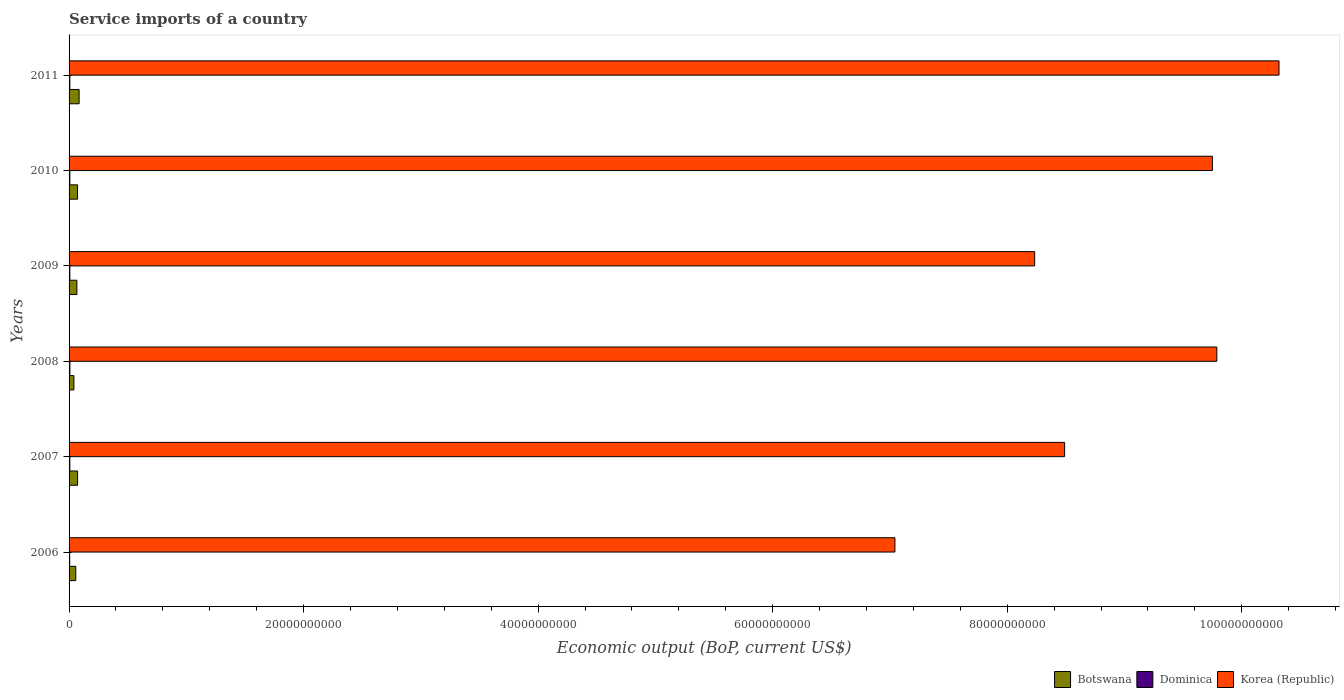How many different coloured bars are there?
Make the answer very short. 3. How many groups of bars are there?
Keep it short and to the point. 6. Are the number of bars per tick equal to the number of legend labels?
Provide a short and direct response. Yes. How many bars are there on the 3rd tick from the bottom?
Make the answer very short. 3. What is the label of the 5th group of bars from the top?
Offer a very short reply. 2007. What is the service imports in Botswana in 2006?
Your response must be concise. 5.72e+08. Across all years, what is the maximum service imports in Botswana?
Make the answer very short. 8.56e+08. Across all years, what is the minimum service imports in Korea (Republic)?
Your response must be concise. 7.04e+1. In which year was the service imports in Korea (Republic) maximum?
Keep it short and to the point. 2011. In which year was the service imports in Dominica minimum?
Provide a short and direct response. 2006. What is the total service imports in Korea (Republic) in the graph?
Make the answer very short. 5.36e+11. What is the difference between the service imports in Dominica in 2009 and that in 2010?
Your answer should be very brief. -1.36e+06. What is the difference between the service imports in Botswana in 2009 and the service imports in Dominica in 2011?
Your response must be concise. 6.01e+08. What is the average service imports in Korea (Republic) per year?
Your answer should be compact. 8.94e+1. In the year 2009, what is the difference between the service imports in Botswana and service imports in Dominica?
Your answer should be compact. 6.00e+08. In how many years, is the service imports in Dominica greater than 88000000000 US$?
Your answer should be very brief. 0. What is the ratio of the service imports in Korea (Republic) in 2006 to that in 2007?
Your answer should be compact. 0.83. Is the service imports in Korea (Republic) in 2010 less than that in 2011?
Your answer should be very brief. Yes. Is the difference between the service imports in Botswana in 2009 and 2011 greater than the difference between the service imports in Dominica in 2009 and 2011?
Offer a very short reply. No. What is the difference between the highest and the second highest service imports in Dominica?
Your answer should be very brief. 2.35e+06. What is the difference between the highest and the lowest service imports in Dominica?
Your answer should be very brief. 1.80e+07. Is the sum of the service imports in Botswana in 2006 and 2008 greater than the maximum service imports in Dominica across all years?
Offer a very short reply. Yes. What does the 3rd bar from the top in 2006 represents?
Make the answer very short. Botswana. What does the 2nd bar from the bottom in 2007 represents?
Give a very brief answer. Dominica. How many bars are there?
Your answer should be very brief. 18. Are the values on the major ticks of X-axis written in scientific E-notation?
Your answer should be very brief. No. Does the graph contain any zero values?
Make the answer very short. No. Does the graph contain grids?
Ensure brevity in your answer.  No. Where does the legend appear in the graph?
Make the answer very short. Bottom right. How are the legend labels stacked?
Make the answer very short. Horizontal. What is the title of the graph?
Offer a terse response. Service imports of a country. What is the label or title of the X-axis?
Make the answer very short. Economic output (BoP, current US$). What is the label or title of the Y-axis?
Your response must be concise. Years. What is the Economic output (BoP, current US$) in Botswana in 2006?
Provide a short and direct response. 5.72e+08. What is the Economic output (BoP, current US$) in Dominica in 2006?
Your response must be concise. 5.20e+07. What is the Economic output (BoP, current US$) in Korea (Republic) in 2006?
Give a very brief answer. 7.04e+1. What is the Economic output (BoP, current US$) of Botswana in 2007?
Your response must be concise. 7.27e+08. What is the Economic output (BoP, current US$) in Dominica in 2007?
Offer a very short reply. 6.40e+07. What is the Economic output (BoP, current US$) in Korea (Republic) in 2007?
Keep it short and to the point. 8.49e+1. What is the Economic output (BoP, current US$) of Botswana in 2008?
Your answer should be very brief. 4.12e+08. What is the Economic output (BoP, current US$) in Dominica in 2008?
Offer a very short reply. 6.99e+07. What is the Economic output (BoP, current US$) in Korea (Republic) in 2008?
Offer a very short reply. 9.79e+1. What is the Economic output (BoP, current US$) in Botswana in 2009?
Provide a succinct answer. 6.67e+08. What is the Economic output (BoP, current US$) in Dominica in 2009?
Your answer should be compact. 6.62e+07. What is the Economic output (BoP, current US$) of Korea (Republic) in 2009?
Provide a short and direct response. 8.23e+1. What is the Economic output (BoP, current US$) of Botswana in 2010?
Make the answer very short. 7.23e+08. What is the Economic output (BoP, current US$) in Dominica in 2010?
Make the answer very short. 6.76e+07. What is the Economic output (BoP, current US$) in Korea (Republic) in 2010?
Your answer should be very brief. 9.75e+1. What is the Economic output (BoP, current US$) in Botswana in 2011?
Give a very brief answer. 8.56e+08. What is the Economic output (BoP, current US$) in Dominica in 2011?
Provide a short and direct response. 6.59e+07. What is the Economic output (BoP, current US$) in Korea (Republic) in 2011?
Keep it short and to the point. 1.03e+11. Across all years, what is the maximum Economic output (BoP, current US$) of Botswana?
Provide a short and direct response. 8.56e+08. Across all years, what is the maximum Economic output (BoP, current US$) in Dominica?
Offer a very short reply. 6.99e+07. Across all years, what is the maximum Economic output (BoP, current US$) in Korea (Republic)?
Offer a very short reply. 1.03e+11. Across all years, what is the minimum Economic output (BoP, current US$) in Botswana?
Keep it short and to the point. 4.12e+08. Across all years, what is the minimum Economic output (BoP, current US$) of Dominica?
Your response must be concise. 5.20e+07. Across all years, what is the minimum Economic output (BoP, current US$) of Korea (Republic)?
Your response must be concise. 7.04e+1. What is the total Economic output (BoP, current US$) in Botswana in the graph?
Your response must be concise. 3.96e+09. What is the total Economic output (BoP, current US$) in Dominica in the graph?
Your answer should be very brief. 3.86e+08. What is the total Economic output (BoP, current US$) in Korea (Republic) in the graph?
Keep it short and to the point. 5.36e+11. What is the difference between the Economic output (BoP, current US$) in Botswana in 2006 and that in 2007?
Offer a terse response. -1.55e+08. What is the difference between the Economic output (BoP, current US$) in Dominica in 2006 and that in 2007?
Your response must be concise. -1.20e+07. What is the difference between the Economic output (BoP, current US$) in Korea (Republic) in 2006 and that in 2007?
Ensure brevity in your answer.  -1.45e+1. What is the difference between the Economic output (BoP, current US$) of Botswana in 2006 and that in 2008?
Ensure brevity in your answer.  1.60e+08. What is the difference between the Economic output (BoP, current US$) in Dominica in 2006 and that in 2008?
Your response must be concise. -1.80e+07. What is the difference between the Economic output (BoP, current US$) in Korea (Republic) in 2006 and that in 2008?
Ensure brevity in your answer.  -2.75e+1. What is the difference between the Economic output (BoP, current US$) of Botswana in 2006 and that in 2009?
Keep it short and to the point. -9.48e+07. What is the difference between the Economic output (BoP, current US$) in Dominica in 2006 and that in 2009?
Offer a terse response. -1.43e+07. What is the difference between the Economic output (BoP, current US$) in Korea (Republic) in 2006 and that in 2009?
Your answer should be very brief. -1.19e+1. What is the difference between the Economic output (BoP, current US$) of Botswana in 2006 and that in 2010?
Offer a very short reply. -1.51e+08. What is the difference between the Economic output (BoP, current US$) of Dominica in 2006 and that in 2010?
Your response must be concise. -1.56e+07. What is the difference between the Economic output (BoP, current US$) in Korea (Republic) in 2006 and that in 2010?
Your answer should be very brief. -2.71e+1. What is the difference between the Economic output (BoP, current US$) of Botswana in 2006 and that in 2011?
Offer a very short reply. -2.84e+08. What is the difference between the Economic output (BoP, current US$) in Dominica in 2006 and that in 2011?
Offer a very short reply. -1.39e+07. What is the difference between the Economic output (BoP, current US$) in Korea (Republic) in 2006 and that in 2011?
Your answer should be very brief. -3.28e+1. What is the difference between the Economic output (BoP, current US$) in Botswana in 2007 and that in 2008?
Your answer should be very brief. 3.16e+08. What is the difference between the Economic output (BoP, current US$) of Dominica in 2007 and that in 2008?
Ensure brevity in your answer.  -5.96e+06. What is the difference between the Economic output (BoP, current US$) of Korea (Republic) in 2007 and that in 2008?
Keep it short and to the point. -1.30e+1. What is the difference between the Economic output (BoP, current US$) in Botswana in 2007 and that in 2009?
Ensure brevity in your answer.  6.05e+07. What is the difference between the Economic output (BoP, current US$) of Dominica in 2007 and that in 2009?
Offer a very short reply. -2.25e+06. What is the difference between the Economic output (BoP, current US$) in Korea (Republic) in 2007 and that in 2009?
Your answer should be compact. 2.56e+09. What is the difference between the Economic output (BoP, current US$) of Botswana in 2007 and that in 2010?
Keep it short and to the point. 4.27e+06. What is the difference between the Economic output (BoP, current US$) in Dominica in 2007 and that in 2010?
Give a very brief answer. -3.61e+06. What is the difference between the Economic output (BoP, current US$) of Korea (Republic) in 2007 and that in 2010?
Offer a terse response. -1.26e+1. What is the difference between the Economic output (BoP, current US$) of Botswana in 2007 and that in 2011?
Your answer should be very brief. -1.29e+08. What is the difference between the Economic output (BoP, current US$) of Dominica in 2007 and that in 2011?
Provide a succinct answer. -1.88e+06. What is the difference between the Economic output (BoP, current US$) in Korea (Republic) in 2007 and that in 2011?
Keep it short and to the point. -1.83e+1. What is the difference between the Economic output (BoP, current US$) in Botswana in 2008 and that in 2009?
Your answer should be very brief. -2.55e+08. What is the difference between the Economic output (BoP, current US$) of Dominica in 2008 and that in 2009?
Ensure brevity in your answer.  3.70e+06. What is the difference between the Economic output (BoP, current US$) in Korea (Republic) in 2008 and that in 2009?
Keep it short and to the point. 1.55e+1. What is the difference between the Economic output (BoP, current US$) in Botswana in 2008 and that in 2010?
Make the answer very short. -3.11e+08. What is the difference between the Economic output (BoP, current US$) of Dominica in 2008 and that in 2010?
Your answer should be very brief. 2.35e+06. What is the difference between the Economic output (BoP, current US$) in Korea (Republic) in 2008 and that in 2010?
Your answer should be very brief. 3.78e+08. What is the difference between the Economic output (BoP, current US$) of Botswana in 2008 and that in 2011?
Your response must be concise. -4.45e+08. What is the difference between the Economic output (BoP, current US$) in Dominica in 2008 and that in 2011?
Give a very brief answer. 4.07e+06. What is the difference between the Economic output (BoP, current US$) of Korea (Republic) in 2008 and that in 2011?
Your answer should be compact. -5.30e+09. What is the difference between the Economic output (BoP, current US$) of Botswana in 2009 and that in 2010?
Ensure brevity in your answer.  -5.62e+07. What is the difference between the Economic output (BoP, current US$) of Dominica in 2009 and that in 2010?
Provide a short and direct response. -1.36e+06. What is the difference between the Economic output (BoP, current US$) in Korea (Republic) in 2009 and that in 2010?
Offer a terse response. -1.52e+1. What is the difference between the Economic output (BoP, current US$) in Botswana in 2009 and that in 2011?
Your answer should be compact. -1.90e+08. What is the difference between the Economic output (BoP, current US$) in Dominica in 2009 and that in 2011?
Your response must be concise. 3.70e+05. What is the difference between the Economic output (BoP, current US$) of Korea (Republic) in 2009 and that in 2011?
Your response must be concise. -2.08e+1. What is the difference between the Economic output (BoP, current US$) of Botswana in 2010 and that in 2011?
Offer a terse response. -1.33e+08. What is the difference between the Economic output (BoP, current US$) of Dominica in 2010 and that in 2011?
Ensure brevity in your answer.  1.73e+06. What is the difference between the Economic output (BoP, current US$) in Korea (Republic) in 2010 and that in 2011?
Your answer should be compact. -5.68e+09. What is the difference between the Economic output (BoP, current US$) of Botswana in 2006 and the Economic output (BoP, current US$) of Dominica in 2007?
Offer a very short reply. 5.08e+08. What is the difference between the Economic output (BoP, current US$) of Botswana in 2006 and the Economic output (BoP, current US$) of Korea (Republic) in 2007?
Your response must be concise. -8.43e+1. What is the difference between the Economic output (BoP, current US$) of Dominica in 2006 and the Economic output (BoP, current US$) of Korea (Republic) in 2007?
Provide a short and direct response. -8.48e+1. What is the difference between the Economic output (BoP, current US$) of Botswana in 2006 and the Economic output (BoP, current US$) of Dominica in 2008?
Provide a succinct answer. 5.02e+08. What is the difference between the Economic output (BoP, current US$) of Botswana in 2006 and the Economic output (BoP, current US$) of Korea (Republic) in 2008?
Ensure brevity in your answer.  -9.73e+1. What is the difference between the Economic output (BoP, current US$) in Dominica in 2006 and the Economic output (BoP, current US$) in Korea (Republic) in 2008?
Give a very brief answer. -9.78e+1. What is the difference between the Economic output (BoP, current US$) in Botswana in 2006 and the Economic output (BoP, current US$) in Dominica in 2009?
Your response must be concise. 5.06e+08. What is the difference between the Economic output (BoP, current US$) in Botswana in 2006 and the Economic output (BoP, current US$) in Korea (Republic) in 2009?
Your answer should be compact. -8.18e+1. What is the difference between the Economic output (BoP, current US$) in Dominica in 2006 and the Economic output (BoP, current US$) in Korea (Republic) in 2009?
Your answer should be compact. -8.23e+1. What is the difference between the Economic output (BoP, current US$) in Botswana in 2006 and the Economic output (BoP, current US$) in Dominica in 2010?
Offer a terse response. 5.04e+08. What is the difference between the Economic output (BoP, current US$) of Botswana in 2006 and the Economic output (BoP, current US$) of Korea (Republic) in 2010?
Your answer should be compact. -9.69e+1. What is the difference between the Economic output (BoP, current US$) in Dominica in 2006 and the Economic output (BoP, current US$) in Korea (Republic) in 2010?
Give a very brief answer. -9.74e+1. What is the difference between the Economic output (BoP, current US$) of Botswana in 2006 and the Economic output (BoP, current US$) of Dominica in 2011?
Your response must be concise. 5.06e+08. What is the difference between the Economic output (BoP, current US$) in Botswana in 2006 and the Economic output (BoP, current US$) in Korea (Republic) in 2011?
Your answer should be compact. -1.03e+11. What is the difference between the Economic output (BoP, current US$) of Dominica in 2006 and the Economic output (BoP, current US$) of Korea (Republic) in 2011?
Provide a short and direct response. -1.03e+11. What is the difference between the Economic output (BoP, current US$) in Botswana in 2007 and the Economic output (BoP, current US$) in Dominica in 2008?
Provide a short and direct response. 6.57e+08. What is the difference between the Economic output (BoP, current US$) of Botswana in 2007 and the Economic output (BoP, current US$) of Korea (Republic) in 2008?
Offer a terse response. -9.71e+1. What is the difference between the Economic output (BoP, current US$) of Dominica in 2007 and the Economic output (BoP, current US$) of Korea (Republic) in 2008?
Make the answer very short. -9.78e+1. What is the difference between the Economic output (BoP, current US$) of Botswana in 2007 and the Economic output (BoP, current US$) of Dominica in 2009?
Keep it short and to the point. 6.61e+08. What is the difference between the Economic output (BoP, current US$) of Botswana in 2007 and the Economic output (BoP, current US$) of Korea (Republic) in 2009?
Keep it short and to the point. -8.16e+1. What is the difference between the Economic output (BoP, current US$) of Dominica in 2007 and the Economic output (BoP, current US$) of Korea (Republic) in 2009?
Your response must be concise. -8.23e+1. What is the difference between the Economic output (BoP, current US$) of Botswana in 2007 and the Economic output (BoP, current US$) of Dominica in 2010?
Keep it short and to the point. 6.60e+08. What is the difference between the Economic output (BoP, current US$) in Botswana in 2007 and the Economic output (BoP, current US$) in Korea (Republic) in 2010?
Provide a short and direct response. -9.68e+1. What is the difference between the Economic output (BoP, current US$) in Dominica in 2007 and the Economic output (BoP, current US$) in Korea (Republic) in 2010?
Your response must be concise. -9.74e+1. What is the difference between the Economic output (BoP, current US$) in Botswana in 2007 and the Economic output (BoP, current US$) in Dominica in 2011?
Keep it short and to the point. 6.61e+08. What is the difference between the Economic output (BoP, current US$) in Botswana in 2007 and the Economic output (BoP, current US$) in Korea (Republic) in 2011?
Your answer should be compact. -1.02e+11. What is the difference between the Economic output (BoP, current US$) in Dominica in 2007 and the Economic output (BoP, current US$) in Korea (Republic) in 2011?
Provide a short and direct response. -1.03e+11. What is the difference between the Economic output (BoP, current US$) in Botswana in 2008 and the Economic output (BoP, current US$) in Dominica in 2009?
Offer a very short reply. 3.45e+08. What is the difference between the Economic output (BoP, current US$) in Botswana in 2008 and the Economic output (BoP, current US$) in Korea (Republic) in 2009?
Provide a succinct answer. -8.19e+1. What is the difference between the Economic output (BoP, current US$) of Dominica in 2008 and the Economic output (BoP, current US$) of Korea (Republic) in 2009?
Your answer should be compact. -8.23e+1. What is the difference between the Economic output (BoP, current US$) in Botswana in 2008 and the Economic output (BoP, current US$) in Dominica in 2010?
Ensure brevity in your answer.  3.44e+08. What is the difference between the Economic output (BoP, current US$) in Botswana in 2008 and the Economic output (BoP, current US$) in Korea (Republic) in 2010?
Give a very brief answer. -9.71e+1. What is the difference between the Economic output (BoP, current US$) of Dominica in 2008 and the Economic output (BoP, current US$) of Korea (Republic) in 2010?
Offer a very short reply. -9.74e+1. What is the difference between the Economic output (BoP, current US$) of Botswana in 2008 and the Economic output (BoP, current US$) of Dominica in 2011?
Provide a succinct answer. 3.46e+08. What is the difference between the Economic output (BoP, current US$) in Botswana in 2008 and the Economic output (BoP, current US$) in Korea (Republic) in 2011?
Your response must be concise. -1.03e+11. What is the difference between the Economic output (BoP, current US$) in Dominica in 2008 and the Economic output (BoP, current US$) in Korea (Republic) in 2011?
Make the answer very short. -1.03e+11. What is the difference between the Economic output (BoP, current US$) of Botswana in 2009 and the Economic output (BoP, current US$) of Dominica in 2010?
Provide a succinct answer. 5.99e+08. What is the difference between the Economic output (BoP, current US$) in Botswana in 2009 and the Economic output (BoP, current US$) in Korea (Republic) in 2010?
Make the answer very short. -9.68e+1. What is the difference between the Economic output (BoP, current US$) in Dominica in 2009 and the Economic output (BoP, current US$) in Korea (Republic) in 2010?
Ensure brevity in your answer.  -9.74e+1. What is the difference between the Economic output (BoP, current US$) in Botswana in 2009 and the Economic output (BoP, current US$) in Dominica in 2011?
Provide a succinct answer. 6.01e+08. What is the difference between the Economic output (BoP, current US$) in Botswana in 2009 and the Economic output (BoP, current US$) in Korea (Republic) in 2011?
Make the answer very short. -1.03e+11. What is the difference between the Economic output (BoP, current US$) in Dominica in 2009 and the Economic output (BoP, current US$) in Korea (Republic) in 2011?
Your response must be concise. -1.03e+11. What is the difference between the Economic output (BoP, current US$) in Botswana in 2010 and the Economic output (BoP, current US$) in Dominica in 2011?
Your response must be concise. 6.57e+08. What is the difference between the Economic output (BoP, current US$) in Botswana in 2010 and the Economic output (BoP, current US$) in Korea (Republic) in 2011?
Provide a short and direct response. -1.02e+11. What is the difference between the Economic output (BoP, current US$) of Dominica in 2010 and the Economic output (BoP, current US$) of Korea (Republic) in 2011?
Provide a short and direct response. -1.03e+11. What is the average Economic output (BoP, current US$) of Botswana per year?
Your answer should be compact. 6.59e+08. What is the average Economic output (BoP, current US$) in Dominica per year?
Offer a terse response. 6.43e+07. What is the average Economic output (BoP, current US$) of Korea (Republic) per year?
Your answer should be compact. 8.94e+1. In the year 2006, what is the difference between the Economic output (BoP, current US$) in Botswana and Economic output (BoP, current US$) in Dominica?
Your response must be concise. 5.20e+08. In the year 2006, what is the difference between the Economic output (BoP, current US$) of Botswana and Economic output (BoP, current US$) of Korea (Republic)?
Your answer should be very brief. -6.99e+1. In the year 2006, what is the difference between the Economic output (BoP, current US$) in Dominica and Economic output (BoP, current US$) in Korea (Republic)?
Offer a very short reply. -7.04e+1. In the year 2007, what is the difference between the Economic output (BoP, current US$) in Botswana and Economic output (BoP, current US$) in Dominica?
Your answer should be very brief. 6.63e+08. In the year 2007, what is the difference between the Economic output (BoP, current US$) of Botswana and Economic output (BoP, current US$) of Korea (Republic)?
Your response must be concise. -8.42e+1. In the year 2007, what is the difference between the Economic output (BoP, current US$) of Dominica and Economic output (BoP, current US$) of Korea (Republic)?
Provide a short and direct response. -8.48e+1. In the year 2008, what is the difference between the Economic output (BoP, current US$) of Botswana and Economic output (BoP, current US$) of Dominica?
Offer a terse response. 3.42e+08. In the year 2008, what is the difference between the Economic output (BoP, current US$) in Botswana and Economic output (BoP, current US$) in Korea (Republic)?
Give a very brief answer. -9.75e+1. In the year 2008, what is the difference between the Economic output (BoP, current US$) of Dominica and Economic output (BoP, current US$) of Korea (Republic)?
Make the answer very short. -9.78e+1. In the year 2009, what is the difference between the Economic output (BoP, current US$) in Botswana and Economic output (BoP, current US$) in Dominica?
Offer a very short reply. 6.00e+08. In the year 2009, what is the difference between the Economic output (BoP, current US$) in Botswana and Economic output (BoP, current US$) in Korea (Republic)?
Offer a terse response. -8.17e+1. In the year 2009, what is the difference between the Economic output (BoP, current US$) of Dominica and Economic output (BoP, current US$) of Korea (Republic)?
Keep it short and to the point. -8.23e+1. In the year 2010, what is the difference between the Economic output (BoP, current US$) in Botswana and Economic output (BoP, current US$) in Dominica?
Give a very brief answer. 6.55e+08. In the year 2010, what is the difference between the Economic output (BoP, current US$) of Botswana and Economic output (BoP, current US$) of Korea (Republic)?
Provide a short and direct response. -9.68e+1. In the year 2010, what is the difference between the Economic output (BoP, current US$) of Dominica and Economic output (BoP, current US$) of Korea (Republic)?
Offer a very short reply. -9.74e+1. In the year 2011, what is the difference between the Economic output (BoP, current US$) in Botswana and Economic output (BoP, current US$) in Dominica?
Your answer should be very brief. 7.90e+08. In the year 2011, what is the difference between the Economic output (BoP, current US$) in Botswana and Economic output (BoP, current US$) in Korea (Republic)?
Ensure brevity in your answer.  -1.02e+11. In the year 2011, what is the difference between the Economic output (BoP, current US$) in Dominica and Economic output (BoP, current US$) in Korea (Republic)?
Offer a terse response. -1.03e+11. What is the ratio of the Economic output (BoP, current US$) of Botswana in 2006 to that in 2007?
Provide a succinct answer. 0.79. What is the ratio of the Economic output (BoP, current US$) in Dominica in 2006 to that in 2007?
Make the answer very short. 0.81. What is the ratio of the Economic output (BoP, current US$) in Korea (Republic) in 2006 to that in 2007?
Ensure brevity in your answer.  0.83. What is the ratio of the Economic output (BoP, current US$) of Botswana in 2006 to that in 2008?
Give a very brief answer. 1.39. What is the ratio of the Economic output (BoP, current US$) in Dominica in 2006 to that in 2008?
Offer a very short reply. 0.74. What is the ratio of the Economic output (BoP, current US$) in Korea (Republic) in 2006 to that in 2008?
Provide a succinct answer. 0.72. What is the ratio of the Economic output (BoP, current US$) in Botswana in 2006 to that in 2009?
Your answer should be very brief. 0.86. What is the ratio of the Economic output (BoP, current US$) of Dominica in 2006 to that in 2009?
Provide a short and direct response. 0.78. What is the ratio of the Economic output (BoP, current US$) in Korea (Republic) in 2006 to that in 2009?
Provide a short and direct response. 0.86. What is the ratio of the Economic output (BoP, current US$) of Botswana in 2006 to that in 2010?
Your response must be concise. 0.79. What is the ratio of the Economic output (BoP, current US$) of Dominica in 2006 to that in 2010?
Keep it short and to the point. 0.77. What is the ratio of the Economic output (BoP, current US$) of Korea (Republic) in 2006 to that in 2010?
Offer a terse response. 0.72. What is the ratio of the Economic output (BoP, current US$) of Botswana in 2006 to that in 2011?
Keep it short and to the point. 0.67. What is the ratio of the Economic output (BoP, current US$) in Dominica in 2006 to that in 2011?
Make the answer very short. 0.79. What is the ratio of the Economic output (BoP, current US$) in Korea (Republic) in 2006 to that in 2011?
Provide a short and direct response. 0.68. What is the ratio of the Economic output (BoP, current US$) in Botswana in 2007 to that in 2008?
Provide a succinct answer. 1.77. What is the ratio of the Economic output (BoP, current US$) in Dominica in 2007 to that in 2008?
Your response must be concise. 0.91. What is the ratio of the Economic output (BoP, current US$) of Korea (Republic) in 2007 to that in 2008?
Your answer should be compact. 0.87. What is the ratio of the Economic output (BoP, current US$) in Botswana in 2007 to that in 2009?
Your answer should be compact. 1.09. What is the ratio of the Economic output (BoP, current US$) in Korea (Republic) in 2007 to that in 2009?
Your response must be concise. 1.03. What is the ratio of the Economic output (BoP, current US$) of Botswana in 2007 to that in 2010?
Make the answer very short. 1.01. What is the ratio of the Economic output (BoP, current US$) of Dominica in 2007 to that in 2010?
Your answer should be very brief. 0.95. What is the ratio of the Economic output (BoP, current US$) of Korea (Republic) in 2007 to that in 2010?
Keep it short and to the point. 0.87. What is the ratio of the Economic output (BoP, current US$) in Botswana in 2007 to that in 2011?
Offer a very short reply. 0.85. What is the ratio of the Economic output (BoP, current US$) in Dominica in 2007 to that in 2011?
Keep it short and to the point. 0.97. What is the ratio of the Economic output (BoP, current US$) in Korea (Republic) in 2007 to that in 2011?
Offer a very short reply. 0.82. What is the ratio of the Economic output (BoP, current US$) of Botswana in 2008 to that in 2009?
Provide a short and direct response. 0.62. What is the ratio of the Economic output (BoP, current US$) in Dominica in 2008 to that in 2009?
Provide a succinct answer. 1.06. What is the ratio of the Economic output (BoP, current US$) of Korea (Republic) in 2008 to that in 2009?
Ensure brevity in your answer.  1.19. What is the ratio of the Economic output (BoP, current US$) in Botswana in 2008 to that in 2010?
Provide a succinct answer. 0.57. What is the ratio of the Economic output (BoP, current US$) of Dominica in 2008 to that in 2010?
Make the answer very short. 1.03. What is the ratio of the Economic output (BoP, current US$) of Botswana in 2008 to that in 2011?
Offer a very short reply. 0.48. What is the ratio of the Economic output (BoP, current US$) of Dominica in 2008 to that in 2011?
Give a very brief answer. 1.06. What is the ratio of the Economic output (BoP, current US$) of Korea (Republic) in 2008 to that in 2011?
Offer a very short reply. 0.95. What is the ratio of the Economic output (BoP, current US$) in Botswana in 2009 to that in 2010?
Give a very brief answer. 0.92. What is the ratio of the Economic output (BoP, current US$) in Dominica in 2009 to that in 2010?
Keep it short and to the point. 0.98. What is the ratio of the Economic output (BoP, current US$) of Korea (Republic) in 2009 to that in 2010?
Ensure brevity in your answer.  0.84. What is the ratio of the Economic output (BoP, current US$) in Botswana in 2009 to that in 2011?
Give a very brief answer. 0.78. What is the ratio of the Economic output (BoP, current US$) of Dominica in 2009 to that in 2011?
Provide a short and direct response. 1.01. What is the ratio of the Economic output (BoP, current US$) in Korea (Republic) in 2009 to that in 2011?
Offer a very short reply. 0.8. What is the ratio of the Economic output (BoP, current US$) of Botswana in 2010 to that in 2011?
Ensure brevity in your answer.  0.84. What is the ratio of the Economic output (BoP, current US$) in Dominica in 2010 to that in 2011?
Offer a terse response. 1.03. What is the ratio of the Economic output (BoP, current US$) of Korea (Republic) in 2010 to that in 2011?
Provide a succinct answer. 0.94. What is the difference between the highest and the second highest Economic output (BoP, current US$) in Botswana?
Provide a short and direct response. 1.29e+08. What is the difference between the highest and the second highest Economic output (BoP, current US$) in Dominica?
Make the answer very short. 2.35e+06. What is the difference between the highest and the second highest Economic output (BoP, current US$) of Korea (Republic)?
Provide a short and direct response. 5.30e+09. What is the difference between the highest and the lowest Economic output (BoP, current US$) of Botswana?
Your answer should be compact. 4.45e+08. What is the difference between the highest and the lowest Economic output (BoP, current US$) of Dominica?
Keep it short and to the point. 1.80e+07. What is the difference between the highest and the lowest Economic output (BoP, current US$) of Korea (Republic)?
Ensure brevity in your answer.  3.28e+1. 